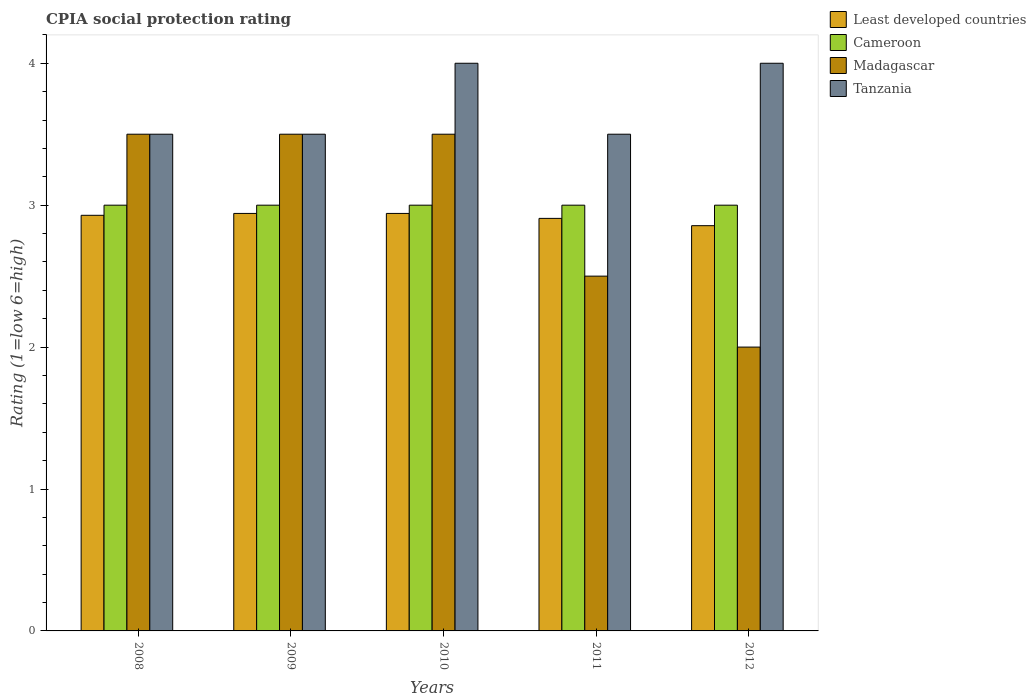How many different coloured bars are there?
Provide a short and direct response. 4. How many bars are there on the 3rd tick from the right?
Your answer should be very brief. 4. What is the label of the 1st group of bars from the left?
Provide a succinct answer. 2008. In how many cases, is the number of bars for a given year not equal to the number of legend labels?
Keep it short and to the point. 0. What is the CPIA rating in Tanzania in 2008?
Ensure brevity in your answer.  3.5. Across all years, what is the maximum CPIA rating in Cameroon?
Ensure brevity in your answer.  3. In which year was the CPIA rating in Tanzania maximum?
Offer a terse response. 2010. In which year was the CPIA rating in Cameroon minimum?
Offer a very short reply. 2008. What is the difference between the CPIA rating in Tanzania in 2011 and that in 2012?
Give a very brief answer. -0.5. What is the difference between the CPIA rating in Least developed countries in 2008 and the CPIA rating in Tanzania in 2012?
Make the answer very short. -1.07. What is the average CPIA rating in Tanzania per year?
Offer a terse response. 3.7. In how many years, is the CPIA rating in Tanzania greater than 3.8?
Offer a very short reply. 2. What is the difference between the highest and the lowest CPIA rating in Least developed countries?
Your response must be concise. 0.09. In how many years, is the CPIA rating in Tanzania greater than the average CPIA rating in Tanzania taken over all years?
Ensure brevity in your answer.  2. Is the sum of the CPIA rating in Tanzania in 2010 and 2011 greater than the maximum CPIA rating in Least developed countries across all years?
Your answer should be very brief. Yes. Is it the case that in every year, the sum of the CPIA rating in Tanzania and CPIA rating in Cameroon is greater than the sum of CPIA rating in Least developed countries and CPIA rating in Madagascar?
Make the answer very short. No. What does the 1st bar from the left in 2010 represents?
Provide a succinct answer. Least developed countries. What does the 1st bar from the right in 2009 represents?
Give a very brief answer. Tanzania. Is it the case that in every year, the sum of the CPIA rating in Least developed countries and CPIA rating in Madagascar is greater than the CPIA rating in Tanzania?
Give a very brief answer. Yes. How many bars are there?
Your response must be concise. 20. Are all the bars in the graph horizontal?
Keep it short and to the point. No. How many years are there in the graph?
Your answer should be very brief. 5. What is the difference between two consecutive major ticks on the Y-axis?
Provide a short and direct response. 1. Are the values on the major ticks of Y-axis written in scientific E-notation?
Your answer should be very brief. No. Does the graph contain any zero values?
Ensure brevity in your answer.  No. How many legend labels are there?
Offer a very short reply. 4. What is the title of the graph?
Ensure brevity in your answer.  CPIA social protection rating. What is the label or title of the Y-axis?
Make the answer very short. Rating (1=low 6=high). What is the Rating (1=low 6=high) in Least developed countries in 2008?
Provide a short and direct response. 2.93. What is the Rating (1=low 6=high) in Cameroon in 2008?
Keep it short and to the point. 3. What is the Rating (1=low 6=high) in Least developed countries in 2009?
Your response must be concise. 2.94. What is the Rating (1=low 6=high) of Tanzania in 2009?
Provide a short and direct response. 3.5. What is the Rating (1=low 6=high) of Least developed countries in 2010?
Offer a very short reply. 2.94. What is the Rating (1=low 6=high) of Tanzania in 2010?
Your answer should be compact. 4. What is the Rating (1=low 6=high) of Least developed countries in 2011?
Provide a succinct answer. 2.91. What is the Rating (1=low 6=high) of Madagascar in 2011?
Offer a very short reply. 2.5. What is the Rating (1=low 6=high) in Tanzania in 2011?
Ensure brevity in your answer.  3.5. What is the Rating (1=low 6=high) in Least developed countries in 2012?
Your answer should be compact. 2.86. What is the Rating (1=low 6=high) in Cameroon in 2012?
Your response must be concise. 3. What is the Rating (1=low 6=high) of Madagascar in 2012?
Provide a succinct answer. 2. What is the Rating (1=low 6=high) in Tanzania in 2012?
Offer a terse response. 4. Across all years, what is the maximum Rating (1=low 6=high) in Least developed countries?
Your answer should be compact. 2.94. Across all years, what is the maximum Rating (1=low 6=high) in Cameroon?
Keep it short and to the point. 3. Across all years, what is the minimum Rating (1=low 6=high) in Least developed countries?
Offer a terse response. 2.86. Across all years, what is the minimum Rating (1=low 6=high) of Madagascar?
Your answer should be very brief. 2. What is the total Rating (1=low 6=high) in Least developed countries in the graph?
Make the answer very short. 14.57. What is the total Rating (1=low 6=high) of Cameroon in the graph?
Offer a very short reply. 15. What is the total Rating (1=low 6=high) of Tanzania in the graph?
Your answer should be very brief. 18.5. What is the difference between the Rating (1=low 6=high) of Least developed countries in 2008 and that in 2009?
Offer a terse response. -0.01. What is the difference between the Rating (1=low 6=high) in Cameroon in 2008 and that in 2009?
Your answer should be very brief. 0. What is the difference between the Rating (1=low 6=high) of Tanzania in 2008 and that in 2009?
Make the answer very short. 0. What is the difference between the Rating (1=low 6=high) in Least developed countries in 2008 and that in 2010?
Offer a very short reply. -0.01. What is the difference between the Rating (1=low 6=high) of Cameroon in 2008 and that in 2010?
Provide a short and direct response. 0. What is the difference between the Rating (1=low 6=high) in Least developed countries in 2008 and that in 2011?
Your answer should be compact. 0.02. What is the difference between the Rating (1=low 6=high) of Madagascar in 2008 and that in 2011?
Your answer should be compact. 1. What is the difference between the Rating (1=low 6=high) in Least developed countries in 2008 and that in 2012?
Offer a terse response. 0.07. What is the difference between the Rating (1=low 6=high) in Cameroon in 2008 and that in 2012?
Your answer should be very brief. 0. What is the difference between the Rating (1=low 6=high) in Tanzania in 2008 and that in 2012?
Provide a short and direct response. -0.5. What is the difference between the Rating (1=low 6=high) in Cameroon in 2009 and that in 2010?
Your answer should be compact. 0. What is the difference between the Rating (1=low 6=high) of Madagascar in 2009 and that in 2010?
Ensure brevity in your answer.  0. What is the difference between the Rating (1=low 6=high) of Least developed countries in 2009 and that in 2011?
Give a very brief answer. 0.03. What is the difference between the Rating (1=low 6=high) of Madagascar in 2009 and that in 2011?
Provide a succinct answer. 1. What is the difference between the Rating (1=low 6=high) of Tanzania in 2009 and that in 2011?
Your response must be concise. 0. What is the difference between the Rating (1=low 6=high) of Least developed countries in 2009 and that in 2012?
Provide a short and direct response. 0.09. What is the difference between the Rating (1=low 6=high) in Tanzania in 2009 and that in 2012?
Your response must be concise. -0.5. What is the difference between the Rating (1=low 6=high) in Least developed countries in 2010 and that in 2011?
Offer a terse response. 0.03. What is the difference between the Rating (1=low 6=high) in Cameroon in 2010 and that in 2011?
Your answer should be very brief. 0. What is the difference between the Rating (1=low 6=high) of Madagascar in 2010 and that in 2011?
Your answer should be very brief. 1. What is the difference between the Rating (1=low 6=high) in Least developed countries in 2010 and that in 2012?
Provide a short and direct response. 0.09. What is the difference between the Rating (1=low 6=high) of Tanzania in 2010 and that in 2012?
Provide a succinct answer. 0. What is the difference between the Rating (1=low 6=high) of Least developed countries in 2011 and that in 2012?
Your answer should be very brief. 0.05. What is the difference between the Rating (1=low 6=high) of Cameroon in 2011 and that in 2012?
Make the answer very short. 0. What is the difference between the Rating (1=low 6=high) in Madagascar in 2011 and that in 2012?
Your answer should be very brief. 0.5. What is the difference between the Rating (1=low 6=high) of Tanzania in 2011 and that in 2012?
Provide a succinct answer. -0.5. What is the difference between the Rating (1=low 6=high) in Least developed countries in 2008 and the Rating (1=low 6=high) in Cameroon in 2009?
Your response must be concise. -0.07. What is the difference between the Rating (1=low 6=high) in Least developed countries in 2008 and the Rating (1=low 6=high) in Madagascar in 2009?
Provide a short and direct response. -0.57. What is the difference between the Rating (1=low 6=high) in Least developed countries in 2008 and the Rating (1=low 6=high) in Tanzania in 2009?
Offer a terse response. -0.57. What is the difference between the Rating (1=low 6=high) in Cameroon in 2008 and the Rating (1=low 6=high) in Madagascar in 2009?
Provide a short and direct response. -0.5. What is the difference between the Rating (1=low 6=high) in Least developed countries in 2008 and the Rating (1=low 6=high) in Cameroon in 2010?
Offer a terse response. -0.07. What is the difference between the Rating (1=low 6=high) in Least developed countries in 2008 and the Rating (1=low 6=high) in Madagascar in 2010?
Offer a terse response. -0.57. What is the difference between the Rating (1=low 6=high) in Least developed countries in 2008 and the Rating (1=low 6=high) in Tanzania in 2010?
Offer a very short reply. -1.07. What is the difference between the Rating (1=low 6=high) in Cameroon in 2008 and the Rating (1=low 6=high) in Tanzania in 2010?
Provide a succinct answer. -1. What is the difference between the Rating (1=low 6=high) of Madagascar in 2008 and the Rating (1=low 6=high) of Tanzania in 2010?
Make the answer very short. -0.5. What is the difference between the Rating (1=low 6=high) of Least developed countries in 2008 and the Rating (1=low 6=high) of Cameroon in 2011?
Your response must be concise. -0.07. What is the difference between the Rating (1=low 6=high) of Least developed countries in 2008 and the Rating (1=low 6=high) of Madagascar in 2011?
Keep it short and to the point. 0.43. What is the difference between the Rating (1=low 6=high) in Least developed countries in 2008 and the Rating (1=low 6=high) in Tanzania in 2011?
Offer a terse response. -0.57. What is the difference between the Rating (1=low 6=high) of Cameroon in 2008 and the Rating (1=low 6=high) of Madagascar in 2011?
Your response must be concise. 0.5. What is the difference between the Rating (1=low 6=high) in Least developed countries in 2008 and the Rating (1=low 6=high) in Cameroon in 2012?
Keep it short and to the point. -0.07. What is the difference between the Rating (1=low 6=high) of Least developed countries in 2008 and the Rating (1=low 6=high) of Madagascar in 2012?
Ensure brevity in your answer.  0.93. What is the difference between the Rating (1=low 6=high) of Least developed countries in 2008 and the Rating (1=low 6=high) of Tanzania in 2012?
Give a very brief answer. -1.07. What is the difference between the Rating (1=low 6=high) in Cameroon in 2008 and the Rating (1=low 6=high) in Madagascar in 2012?
Make the answer very short. 1. What is the difference between the Rating (1=low 6=high) of Cameroon in 2008 and the Rating (1=low 6=high) of Tanzania in 2012?
Your answer should be compact. -1. What is the difference between the Rating (1=low 6=high) in Madagascar in 2008 and the Rating (1=low 6=high) in Tanzania in 2012?
Provide a succinct answer. -0.5. What is the difference between the Rating (1=low 6=high) in Least developed countries in 2009 and the Rating (1=low 6=high) in Cameroon in 2010?
Your response must be concise. -0.06. What is the difference between the Rating (1=low 6=high) in Least developed countries in 2009 and the Rating (1=low 6=high) in Madagascar in 2010?
Provide a succinct answer. -0.56. What is the difference between the Rating (1=low 6=high) of Least developed countries in 2009 and the Rating (1=low 6=high) of Tanzania in 2010?
Ensure brevity in your answer.  -1.06. What is the difference between the Rating (1=low 6=high) in Least developed countries in 2009 and the Rating (1=low 6=high) in Cameroon in 2011?
Keep it short and to the point. -0.06. What is the difference between the Rating (1=low 6=high) of Least developed countries in 2009 and the Rating (1=low 6=high) of Madagascar in 2011?
Provide a succinct answer. 0.44. What is the difference between the Rating (1=low 6=high) of Least developed countries in 2009 and the Rating (1=low 6=high) of Tanzania in 2011?
Offer a terse response. -0.56. What is the difference between the Rating (1=low 6=high) of Madagascar in 2009 and the Rating (1=low 6=high) of Tanzania in 2011?
Offer a terse response. 0. What is the difference between the Rating (1=low 6=high) of Least developed countries in 2009 and the Rating (1=low 6=high) of Cameroon in 2012?
Give a very brief answer. -0.06. What is the difference between the Rating (1=low 6=high) in Least developed countries in 2009 and the Rating (1=low 6=high) in Madagascar in 2012?
Make the answer very short. 0.94. What is the difference between the Rating (1=low 6=high) in Least developed countries in 2009 and the Rating (1=low 6=high) in Tanzania in 2012?
Offer a very short reply. -1.06. What is the difference between the Rating (1=low 6=high) in Least developed countries in 2010 and the Rating (1=low 6=high) in Cameroon in 2011?
Provide a succinct answer. -0.06. What is the difference between the Rating (1=low 6=high) in Least developed countries in 2010 and the Rating (1=low 6=high) in Madagascar in 2011?
Offer a very short reply. 0.44. What is the difference between the Rating (1=low 6=high) of Least developed countries in 2010 and the Rating (1=low 6=high) of Tanzania in 2011?
Offer a terse response. -0.56. What is the difference between the Rating (1=low 6=high) of Cameroon in 2010 and the Rating (1=low 6=high) of Tanzania in 2011?
Ensure brevity in your answer.  -0.5. What is the difference between the Rating (1=low 6=high) of Least developed countries in 2010 and the Rating (1=low 6=high) of Cameroon in 2012?
Offer a terse response. -0.06. What is the difference between the Rating (1=low 6=high) in Least developed countries in 2010 and the Rating (1=low 6=high) in Madagascar in 2012?
Provide a succinct answer. 0.94. What is the difference between the Rating (1=low 6=high) of Least developed countries in 2010 and the Rating (1=low 6=high) of Tanzania in 2012?
Make the answer very short. -1.06. What is the difference between the Rating (1=low 6=high) of Cameroon in 2010 and the Rating (1=low 6=high) of Madagascar in 2012?
Give a very brief answer. 1. What is the difference between the Rating (1=low 6=high) of Madagascar in 2010 and the Rating (1=low 6=high) of Tanzania in 2012?
Make the answer very short. -0.5. What is the difference between the Rating (1=low 6=high) of Least developed countries in 2011 and the Rating (1=low 6=high) of Cameroon in 2012?
Your response must be concise. -0.09. What is the difference between the Rating (1=low 6=high) of Least developed countries in 2011 and the Rating (1=low 6=high) of Madagascar in 2012?
Offer a terse response. 0.91. What is the difference between the Rating (1=low 6=high) in Least developed countries in 2011 and the Rating (1=low 6=high) in Tanzania in 2012?
Keep it short and to the point. -1.09. What is the difference between the Rating (1=low 6=high) of Cameroon in 2011 and the Rating (1=low 6=high) of Tanzania in 2012?
Offer a terse response. -1. What is the difference between the Rating (1=low 6=high) in Madagascar in 2011 and the Rating (1=low 6=high) in Tanzania in 2012?
Provide a succinct answer. -1.5. What is the average Rating (1=low 6=high) in Least developed countries per year?
Provide a succinct answer. 2.92. What is the average Rating (1=low 6=high) in Tanzania per year?
Provide a short and direct response. 3.7. In the year 2008, what is the difference between the Rating (1=low 6=high) in Least developed countries and Rating (1=low 6=high) in Cameroon?
Keep it short and to the point. -0.07. In the year 2008, what is the difference between the Rating (1=low 6=high) in Least developed countries and Rating (1=low 6=high) in Madagascar?
Provide a succinct answer. -0.57. In the year 2008, what is the difference between the Rating (1=low 6=high) in Least developed countries and Rating (1=low 6=high) in Tanzania?
Offer a terse response. -0.57. In the year 2008, what is the difference between the Rating (1=low 6=high) of Cameroon and Rating (1=low 6=high) of Madagascar?
Offer a very short reply. -0.5. In the year 2008, what is the difference between the Rating (1=low 6=high) of Cameroon and Rating (1=low 6=high) of Tanzania?
Provide a succinct answer. -0.5. In the year 2008, what is the difference between the Rating (1=low 6=high) in Madagascar and Rating (1=low 6=high) in Tanzania?
Give a very brief answer. 0. In the year 2009, what is the difference between the Rating (1=low 6=high) of Least developed countries and Rating (1=low 6=high) of Cameroon?
Ensure brevity in your answer.  -0.06. In the year 2009, what is the difference between the Rating (1=low 6=high) in Least developed countries and Rating (1=low 6=high) in Madagascar?
Your response must be concise. -0.56. In the year 2009, what is the difference between the Rating (1=low 6=high) of Least developed countries and Rating (1=low 6=high) of Tanzania?
Make the answer very short. -0.56. In the year 2009, what is the difference between the Rating (1=low 6=high) in Cameroon and Rating (1=low 6=high) in Tanzania?
Ensure brevity in your answer.  -0.5. In the year 2009, what is the difference between the Rating (1=low 6=high) of Madagascar and Rating (1=low 6=high) of Tanzania?
Provide a succinct answer. 0. In the year 2010, what is the difference between the Rating (1=low 6=high) of Least developed countries and Rating (1=low 6=high) of Cameroon?
Your response must be concise. -0.06. In the year 2010, what is the difference between the Rating (1=low 6=high) in Least developed countries and Rating (1=low 6=high) in Madagascar?
Ensure brevity in your answer.  -0.56. In the year 2010, what is the difference between the Rating (1=low 6=high) in Least developed countries and Rating (1=low 6=high) in Tanzania?
Provide a short and direct response. -1.06. In the year 2010, what is the difference between the Rating (1=low 6=high) of Cameroon and Rating (1=low 6=high) of Madagascar?
Keep it short and to the point. -0.5. In the year 2010, what is the difference between the Rating (1=low 6=high) of Cameroon and Rating (1=low 6=high) of Tanzania?
Your answer should be very brief. -1. In the year 2010, what is the difference between the Rating (1=low 6=high) of Madagascar and Rating (1=low 6=high) of Tanzania?
Make the answer very short. -0.5. In the year 2011, what is the difference between the Rating (1=low 6=high) of Least developed countries and Rating (1=low 6=high) of Cameroon?
Your response must be concise. -0.09. In the year 2011, what is the difference between the Rating (1=low 6=high) in Least developed countries and Rating (1=low 6=high) in Madagascar?
Your answer should be compact. 0.41. In the year 2011, what is the difference between the Rating (1=low 6=high) in Least developed countries and Rating (1=low 6=high) in Tanzania?
Give a very brief answer. -0.59. In the year 2011, what is the difference between the Rating (1=low 6=high) in Cameroon and Rating (1=low 6=high) in Madagascar?
Offer a terse response. 0.5. In the year 2012, what is the difference between the Rating (1=low 6=high) in Least developed countries and Rating (1=low 6=high) in Cameroon?
Your answer should be compact. -0.14. In the year 2012, what is the difference between the Rating (1=low 6=high) of Least developed countries and Rating (1=low 6=high) of Madagascar?
Ensure brevity in your answer.  0.86. In the year 2012, what is the difference between the Rating (1=low 6=high) in Least developed countries and Rating (1=low 6=high) in Tanzania?
Give a very brief answer. -1.14. In the year 2012, what is the difference between the Rating (1=low 6=high) of Cameroon and Rating (1=low 6=high) of Tanzania?
Make the answer very short. -1. What is the ratio of the Rating (1=low 6=high) in Least developed countries in 2008 to that in 2009?
Make the answer very short. 1. What is the ratio of the Rating (1=low 6=high) of Madagascar in 2008 to that in 2009?
Your answer should be very brief. 1. What is the ratio of the Rating (1=low 6=high) of Cameroon in 2008 to that in 2010?
Give a very brief answer. 1. What is the ratio of the Rating (1=low 6=high) in Madagascar in 2008 to that in 2010?
Your response must be concise. 1. What is the ratio of the Rating (1=low 6=high) in Tanzania in 2008 to that in 2010?
Provide a succinct answer. 0.88. What is the ratio of the Rating (1=low 6=high) in Least developed countries in 2008 to that in 2011?
Ensure brevity in your answer.  1.01. What is the ratio of the Rating (1=low 6=high) in Cameroon in 2008 to that in 2011?
Your response must be concise. 1. What is the ratio of the Rating (1=low 6=high) of Least developed countries in 2008 to that in 2012?
Provide a succinct answer. 1.03. What is the ratio of the Rating (1=low 6=high) of Cameroon in 2009 to that in 2010?
Your answer should be very brief. 1. What is the ratio of the Rating (1=low 6=high) of Madagascar in 2009 to that in 2010?
Keep it short and to the point. 1. What is the ratio of the Rating (1=low 6=high) in Least developed countries in 2009 to that in 2011?
Provide a short and direct response. 1.01. What is the ratio of the Rating (1=low 6=high) in Cameroon in 2009 to that in 2011?
Provide a succinct answer. 1. What is the ratio of the Rating (1=low 6=high) of Tanzania in 2009 to that in 2011?
Your response must be concise. 1. What is the ratio of the Rating (1=low 6=high) of Least developed countries in 2009 to that in 2012?
Offer a very short reply. 1.03. What is the ratio of the Rating (1=low 6=high) in Tanzania in 2010 to that in 2011?
Ensure brevity in your answer.  1.14. What is the ratio of the Rating (1=low 6=high) of Least developed countries in 2010 to that in 2012?
Offer a very short reply. 1.03. What is the ratio of the Rating (1=low 6=high) in Tanzania in 2010 to that in 2012?
Offer a terse response. 1. What is the ratio of the Rating (1=low 6=high) in Madagascar in 2011 to that in 2012?
Make the answer very short. 1.25. What is the difference between the highest and the second highest Rating (1=low 6=high) in Least developed countries?
Keep it short and to the point. 0. What is the difference between the highest and the second highest Rating (1=low 6=high) of Cameroon?
Provide a short and direct response. 0. What is the difference between the highest and the lowest Rating (1=low 6=high) in Least developed countries?
Keep it short and to the point. 0.09. What is the difference between the highest and the lowest Rating (1=low 6=high) in Cameroon?
Keep it short and to the point. 0. 